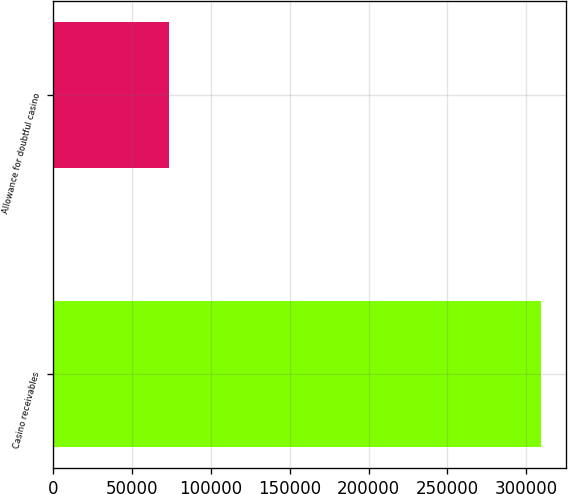Convert chart to OTSL. <chart><loc_0><loc_0><loc_500><loc_500><bar_chart><fcel>Casino receivables<fcel>Allowance for doubtful casino<nl><fcel>309620<fcel>73081<nl></chart> 